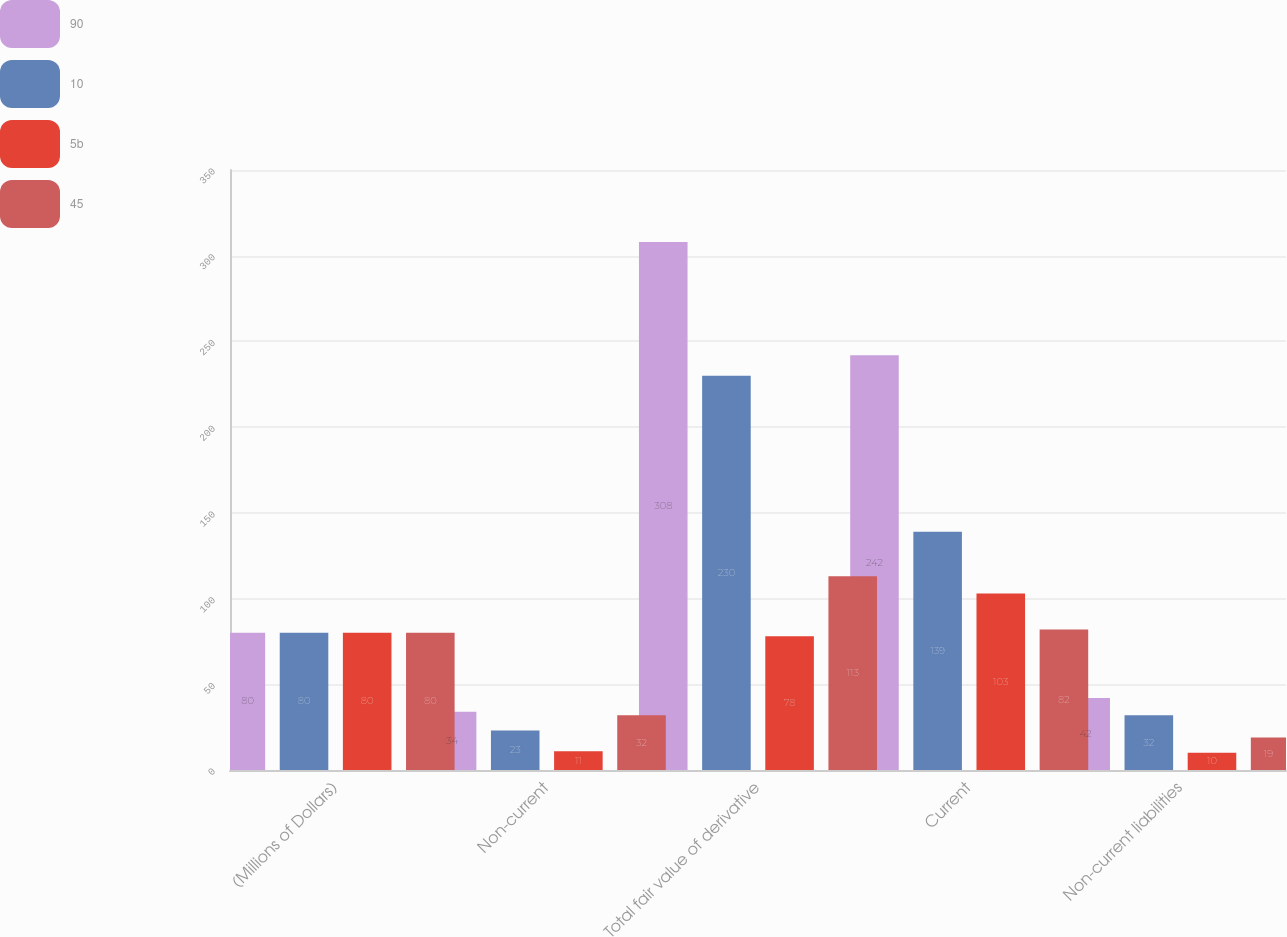Convert chart. <chart><loc_0><loc_0><loc_500><loc_500><stacked_bar_chart><ecel><fcel>(Millions of Dollars)<fcel>Non-current<fcel>Total fair value of derivative<fcel>Current<fcel>Non-current liabilities<nl><fcel>90<fcel>80<fcel>34<fcel>308<fcel>242<fcel>42<nl><fcel>10<fcel>80<fcel>23<fcel>230<fcel>139<fcel>32<nl><fcel>5b<fcel>80<fcel>11<fcel>78<fcel>103<fcel>10<nl><fcel>45<fcel>80<fcel>32<fcel>113<fcel>82<fcel>19<nl></chart> 